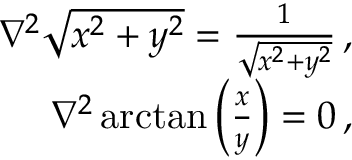<formula> <loc_0><loc_0><loc_500><loc_500>\begin{array} { r } { \nabla ^ { 2 } \sqrt { x ^ { 2 } + y ^ { 2 } } = \frac { 1 } { \sqrt { x ^ { 2 } + y ^ { 2 } } } \, , } \\ { \nabla ^ { 2 } \arctan \left ( \frac { x } { y } \right ) = 0 \, , } \end{array}</formula> 